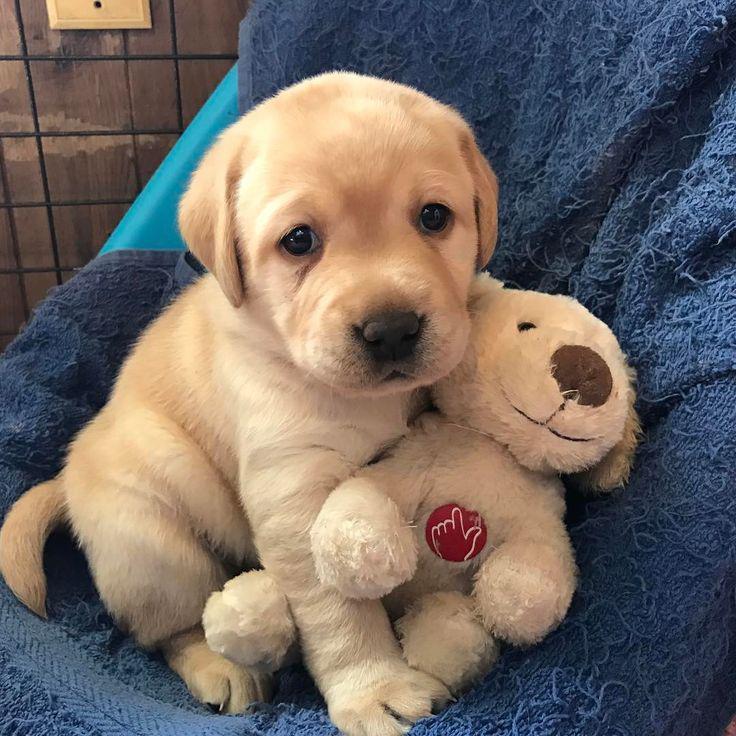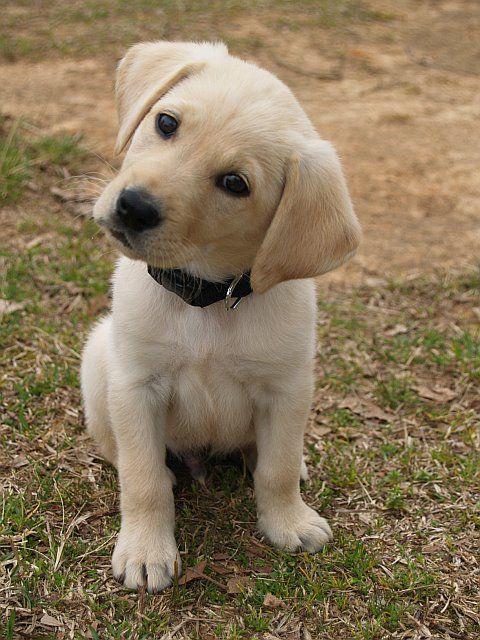The first image is the image on the left, the second image is the image on the right. For the images displayed, is the sentence "Right image shows a pale puppy with some kind of play-thing." factually correct? Answer yes or no. No. The first image is the image on the left, the second image is the image on the right. Considering the images on both sides, is "Two little dogs are shown, one with a toy." valid? Answer yes or no. Yes. 